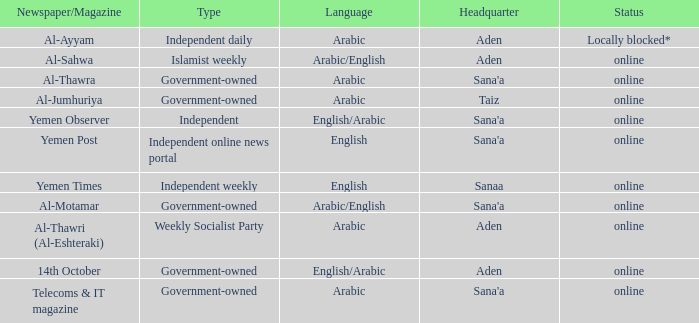What is the main office location for an independent online news portal? Sana'a. 